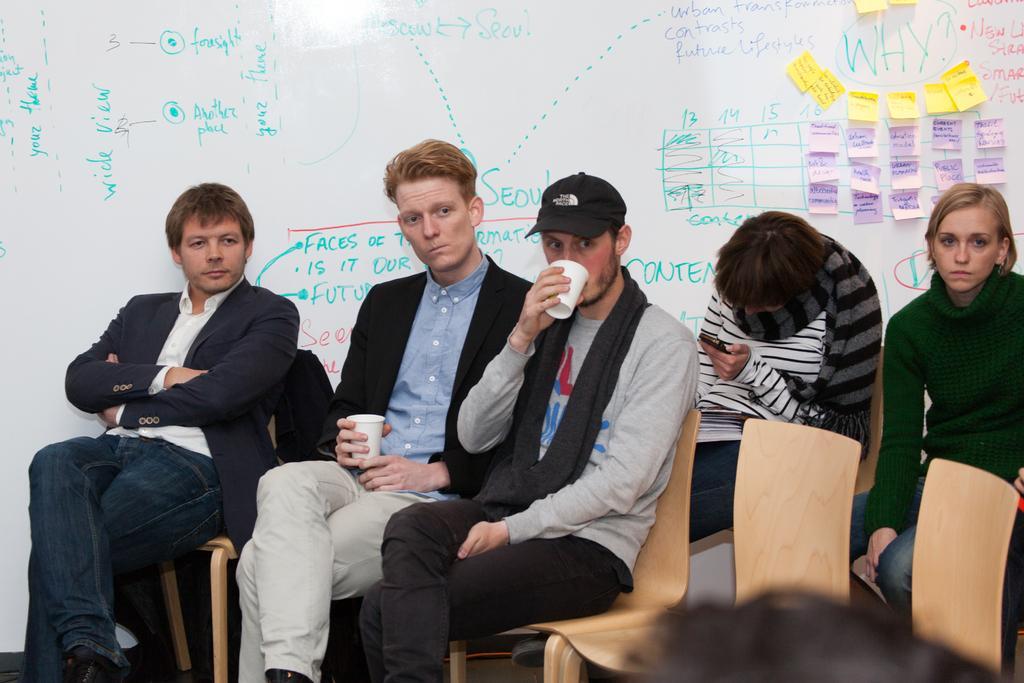Describe this image in one or two sentences. In this image we can see people sitting on the chairs. The men sitting in the center are holding glasses. In the background there is a board and we can see text written on the board. 